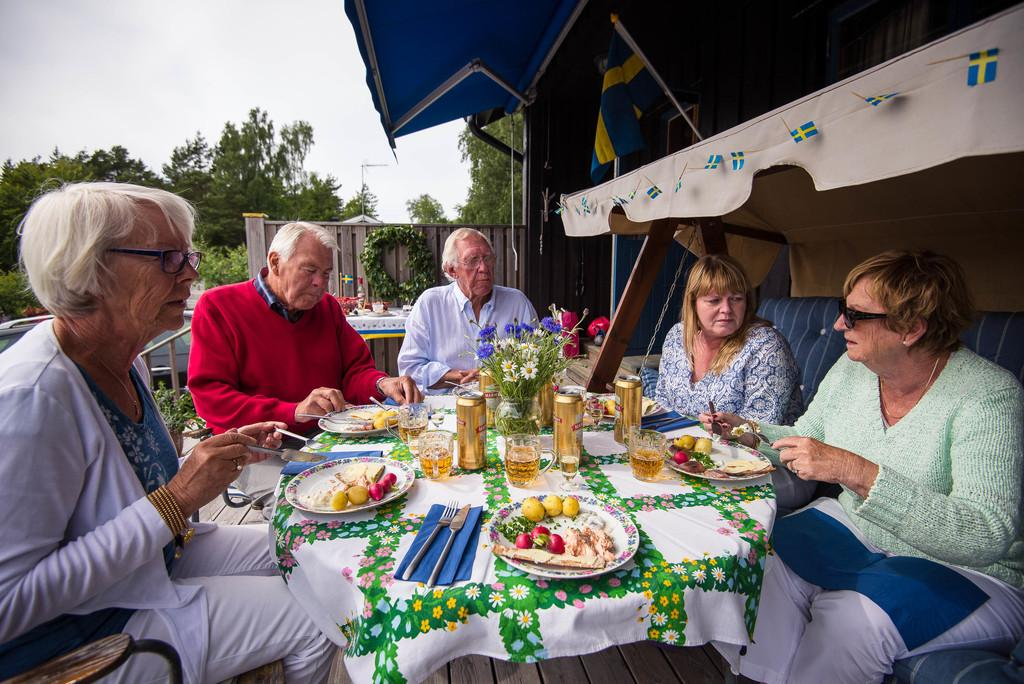What type of vegetation can be seen in the image? There are trees in the image. What part of the natural environment is visible in the image? The sky is visible in the image. What type of furniture is present in the image? There are chairs, a sofa, and a table in the image. What items are on the table in the image? On the table, there is a fork, a spoon, a knife, plates, tins, a glass, and fruits. What time is displayed on the clock in the image? There is no clock present in the image. Who is the representative sitting on the sofa in the image? There is no representative or specific person mentioned in the image. 